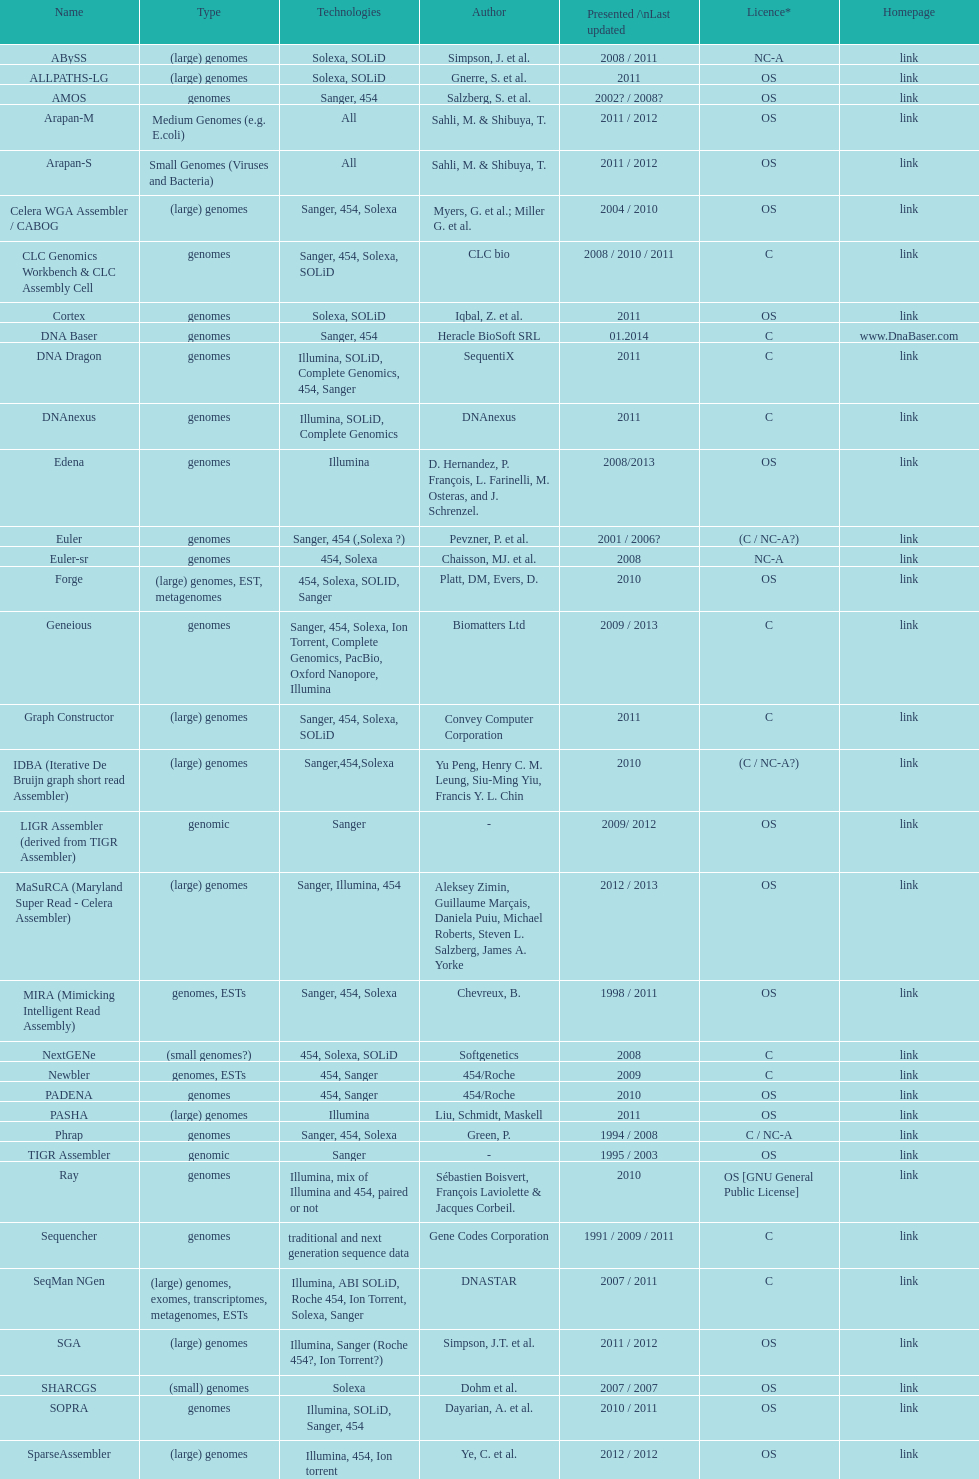Which permit is mentioned more frequently, os or c? OS. 